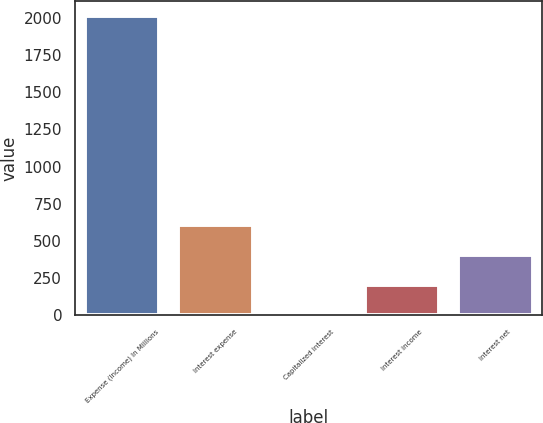Convert chart to OTSL. <chart><loc_0><loc_0><loc_500><loc_500><bar_chart><fcel>Expense (Income) In Millions<fcel>Interest expense<fcel>Capitalized interest<fcel>Interest income<fcel>Interest net<nl><fcel>2013<fcel>606.91<fcel>4.3<fcel>205.17<fcel>406.04<nl></chart> 